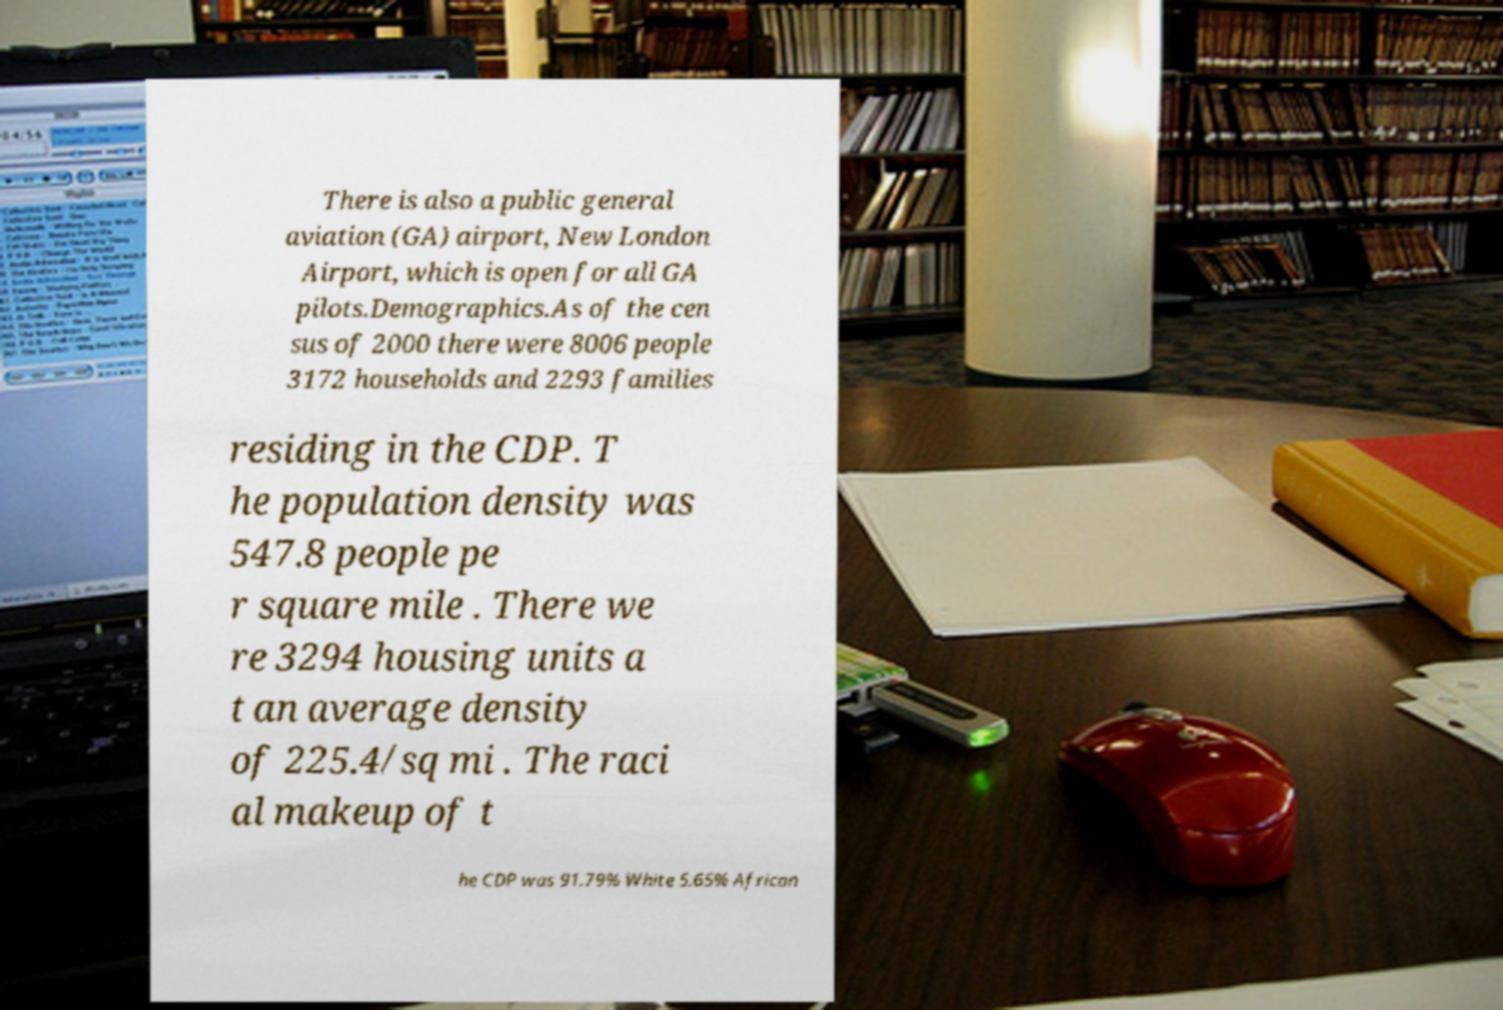I need the written content from this picture converted into text. Can you do that? There is also a public general aviation (GA) airport, New London Airport, which is open for all GA pilots.Demographics.As of the cen sus of 2000 there were 8006 people 3172 households and 2293 families residing in the CDP. T he population density was 547.8 people pe r square mile . There we re 3294 housing units a t an average density of 225.4/sq mi . The raci al makeup of t he CDP was 91.79% White 5.65% African 